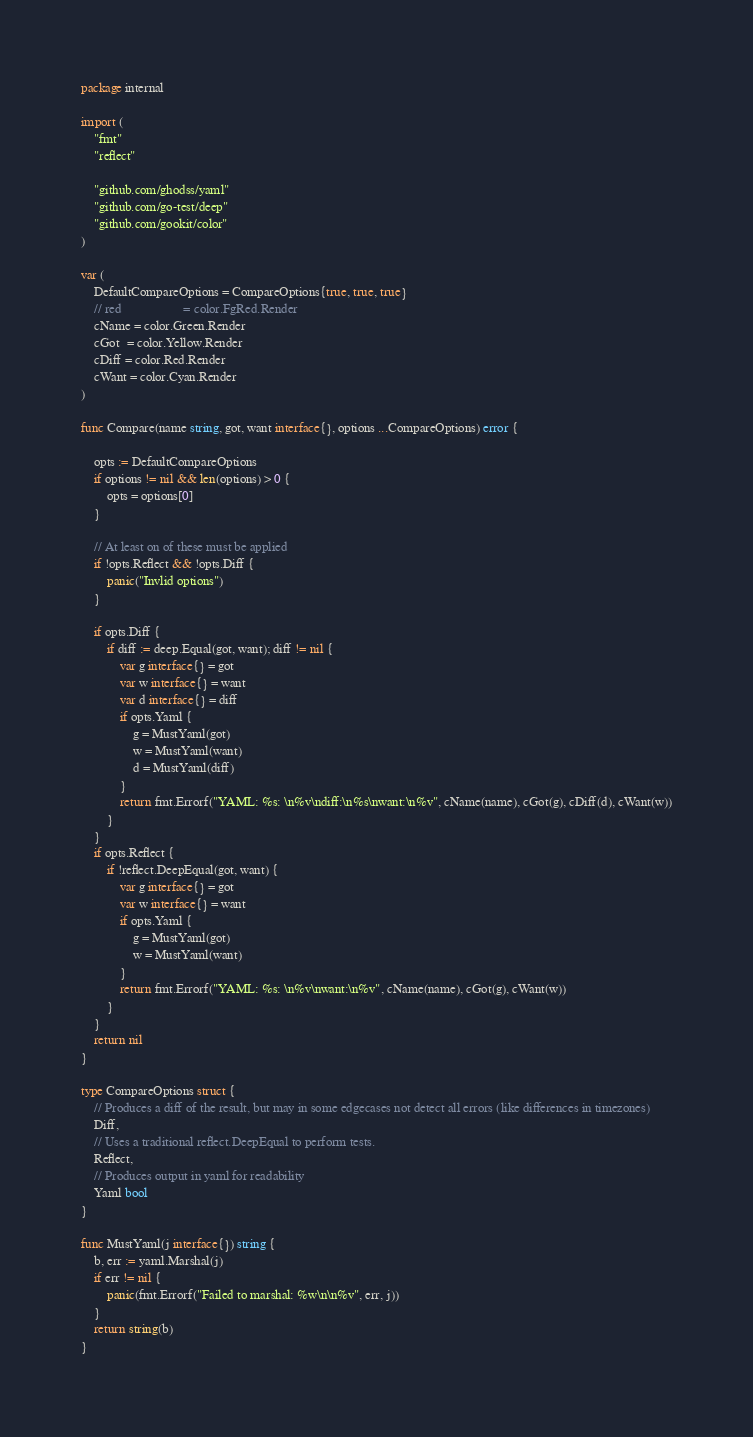<code> <loc_0><loc_0><loc_500><loc_500><_Go_>package internal

import (
	"fmt"
	"reflect"

	"github.com/ghodss/yaml"
	"github.com/go-test/deep"
	"github.com/gookit/color"
)

var (
	DefaultCompareOptions = CompareOptions{true, true, true}
	// red                   = color.FgRed.Render
	cName = color.Green.Render
	cGot  = color.Yellow.Render
	cDiff = color.Red.Render
	cWant = color.Cyan.Render
)

func Compare(name string, got, want interface{}, options ...CompareOptions) error {

	opts := DefaultCompareOptions
	if options != nil && len(options) > 0 {
		opts = options[0]
	}

	// At least on of these must be applied
	if !opts.Reflect && !opts.Diff {
		panic("Invlid options")
	}

	if opts.Diff {
		if diff := deep.Equal(got, want); diff != nil {
			var g interface{} = got
			var w interface{} = want
			var d interface{} = diff
			if opts.Yaml {
				g = MustYaml(got)
				w = MustYaml(want)
				d = MustYaml(diff)
			}
			return fmt.Errorf("YAML: %s: \n%v\ndiff:\n%s\nwant:\n%v", cName(name), cGot(g), cDiff(d), cWant(w))
		}
	}
	if opts.Reflect {
		if !reflect.DeepEqual(got, want) {
			var g interface{} = got
			var w interface{} = want
			if opts.Yaml {
				g = MustYaml(got)
				w = MustYaml(want)
			}
			return fmt.Errorf("YAML: %s: \n%v\nwant:\n%v", cName(name), cGot(g), cWant(w))
		}
	}
	return nil
}

type CompareOptions struct {
	// Produces a diff of the result, but may in some edgecases not detect all errors (like differences in timezones)
	Diff,
	// Uses a traditional reflect.DeepEqual to perform tests.
	Reflect,
	// Produces output in yaml for readability
	Yaml bool
}

func MustYaml(j interface{}) string {
	b, err := yaml.Marshal(j)
	if err != nil {
		panic(fmt.Errorf("Failed to marshal: %w\n\n%v", err, j))
	}
	return string(b)
}
</code> 